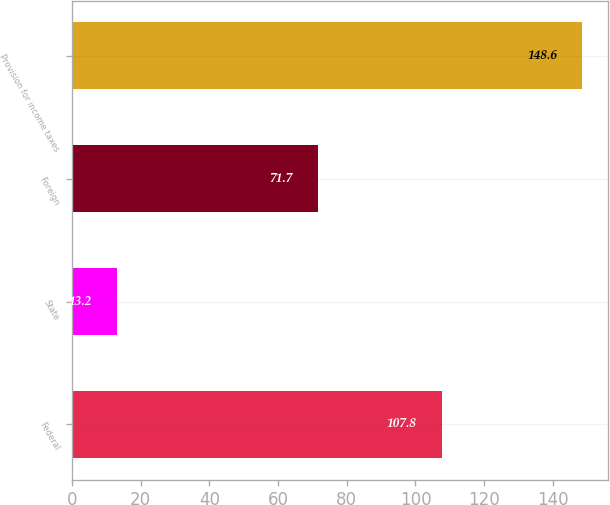Convert chart. <chart><loc_0><loc_0><loc_500><loc_500><bar_chart><fcel>Federal<fcel>State<fcel>Foreign<fcel>Provision for income taxes<nl><fcel>107.8<fcel>13.2<fcel>71.7<fcel>148.6<nl></chart> 